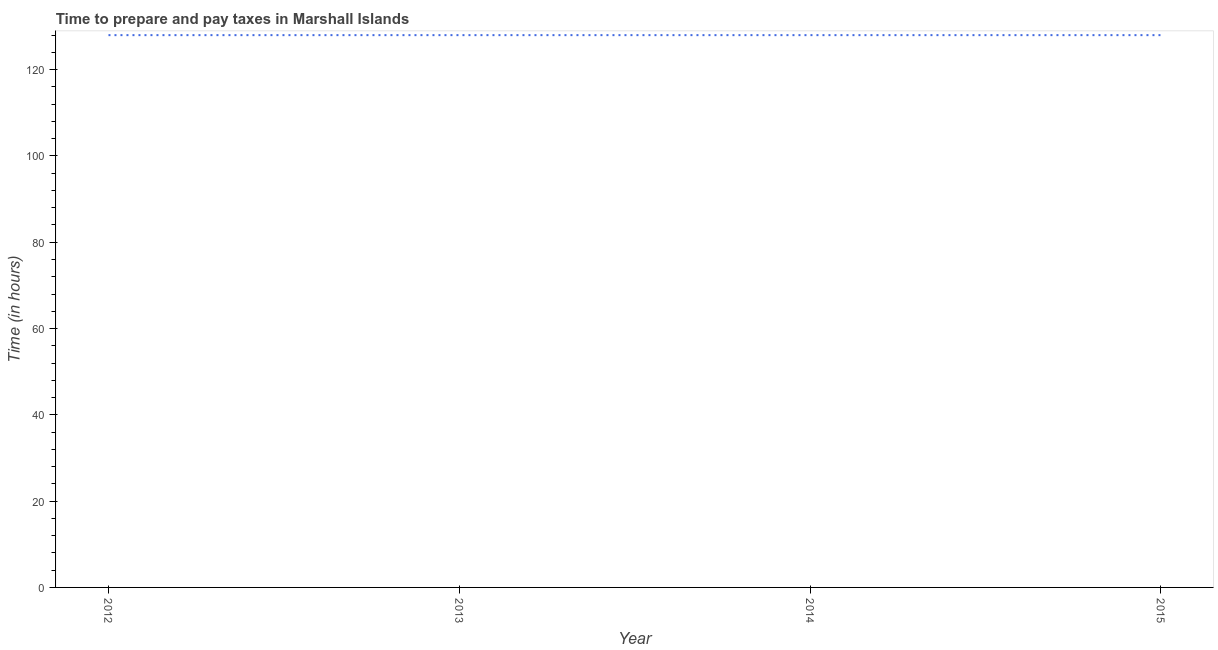What is the time to prepare and pay taxes in 2012?
Provide a short and direct response. 128. Across all years, what is the maximum time to prepare and pay taxes?
Offer a very short reply. 128. Across all years, what is the minimum time to prepare and pay taxes?
Offer a very short reply. 128. In which year was the time to prepare and pay taxes maximum?
Provide a short and direct response. 2012. In which year was the time to prepare and pay taxes minimum?
Make the answer very short. 2012. What is the sum of the time to prepare and pay taxes?
Your answer should be compact. 512. What is the difference between the time to prepare and pay taxes in 2012 and 2015?
Your response must be concise. 0. What is the average time to prepare and pay taxes per year?
Offer a very short reply. 128. What is the median time to prepare and pay taxes?
Ensure brevity in your answer.  128. In how many years, is the time to prepare and pay taxes greater than 40 hours?
Your answer should be compact. 4. What is the ratio of the time to prepare and pay taxes in 2012 to that in 2015?
Ensure brevity in your answer.  1. What is the difference between the highest and the second highest time to prepare and pay taxes?
Keep it short and to the point. 0. In how many years, is the time to prepare and pay taxes greater than the average time to prepare and pay taxes taken over all years?
Your answer should be compact. 0. How many years are there in the graph?
Ensure brevity in your answer.  4. What is the difference between two consecutive major ticks on the Y-axis?
Your response must be concise. 20. Does the graph contain any zero values?
Your answer should be very brief. No. What is the title of the graph?
Provide a succinct answer. Time to prepare and pay taxes in Marshall Islands. What is the label or title of the Y-axis?
Give a very brief answer. Time (in hours). What is the Time (in hours) of 2012?
Your answer should be compact. 128. What is the Time (in hours) in 2013?
Ensure brevity in your answer.  128. What is the Time (in hours) in 2014?
Offer a terse response. 128. What is the Time (in hours) of 2015?
Your answer should be compact. 128. What is the difference between the Time (in hours) in 2012 and 2013?
Offer a terse response. 0. What is the difference between the Time (in hours) in 2012 and 2014?
Provide a succinct answer. 0. What is the difference between the Time (in hours) in 2013 and 2014?
Your answer should be very brief. 0. What is the difference between the Time (in hours) in 2013 and 2015?
Provide a short and direct response. 0. What is the ratio of the Time (in hours) in 2012 to that in 2013?
Offer a very short reply. 1. What is the ratio of the Time (in hours) in 2012 to that in 2015?
Make the answer very short. 1. What is the ratio of the Time (in hours) in 2013 to that in 2014?
Make the answer very short. 1. What is the ratio of the Time (in hours) in 2013 to that in 2015?
Ensure brevity in your answer.  1. 